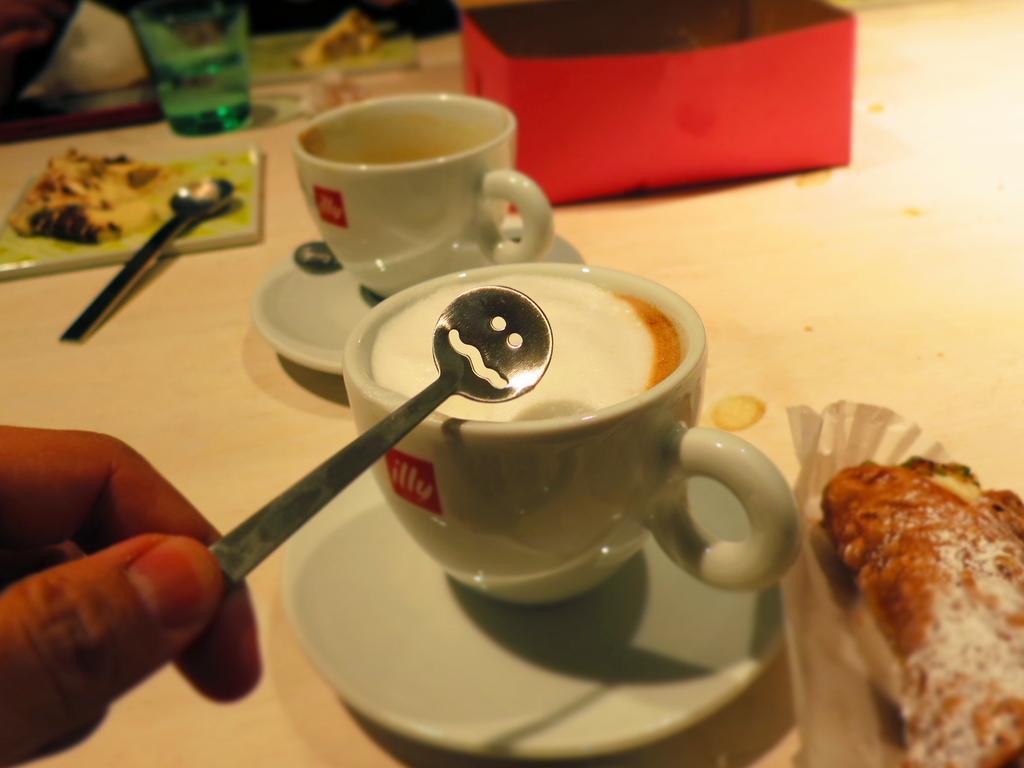How would you summarize this image in a sentence or two? In this image I can see a hand of a person is holding a spoon. I can also see few white colour cups, few white colour plates, one more spoon, a green colour thing, a glass and I can see food on few things. In the background I can see few other stuffs and I can see this image is little bit blurry from background. 